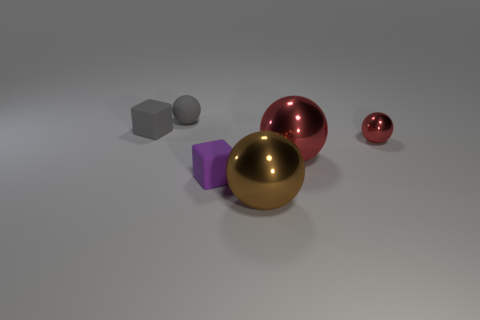There is a small block that is left of the tiny sphere that is on the left side of the large brown sphere; what color is it?
Offer a very short reply. Gray. There is a small red object that is the same shape as the brown object; what material is it?
Your answer should be compact. Metal. What color is the tiny rubber object that is in front of the small sphere that is on the right side of the large metallic sphere in front of the small purple thing?
Offer a terse response. Purple. What number of objects are either gray matte balls or large gray matte balls?
Offer a terse response. 1. How many red things are the same shape as the brown metal object?
Offer a terse response. 2. Are the purple block and the tiny ball in front of the gray ball made of the same material?
Provide a succinct answer. No. The gray cube that is the same material as the purple block is what size?
Offer a terse response. Small. There is a metallic thing in front of the small purple cube; how big is it?
Your answer should be compact. Large. How many other gray rubber cubes have the same size as the gray rubber block?
Keep it short and to the point. 0. What is the size of the block that is the same color as the rubber sphere?
Your response must be concise. Small. 